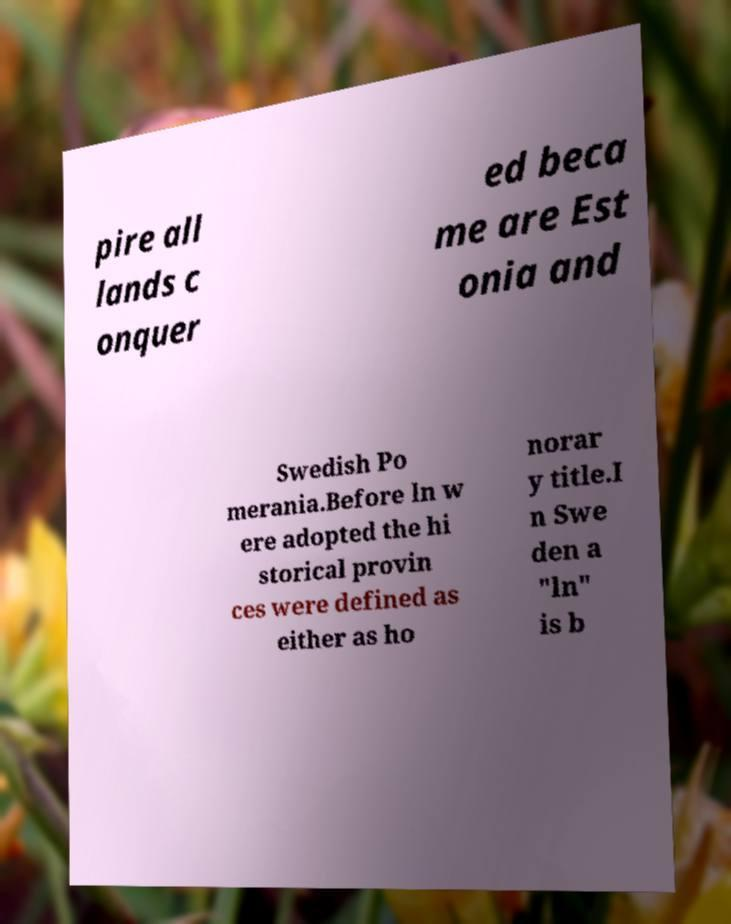Can you read and provide the text displayed in the image?This photo seems to have some interesting text. Can you extract and type it out for me? pire all lands c onquer ed beca me are Est onia and Swedish Po merania.Before ln w ere adopted the hi storical provin ces were defined as either as ho norar y title.I n Swe den a "ln" is b 